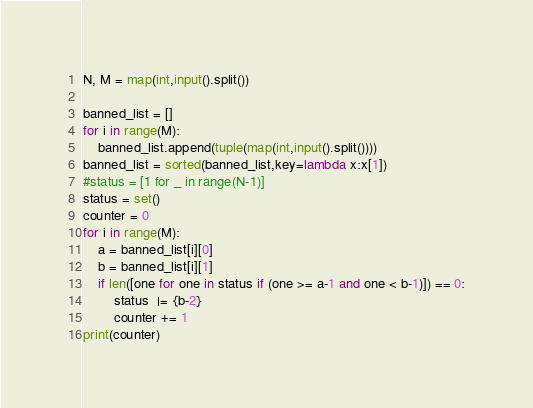<code> <loc_0><loc_0><loc_500><loc_500><_Python_>N, M = map(int,input().split())

banned_list = []
for i in range(M):
    banned_list.append(tuple(map(int,input().split())))
banned_list = sorted(banned_list,key=lambda x:x[1])
#status = [1 for _ in range(N-1)]
status = set()
counter = 0
for i in range(M):
    a = banned_list[i][0]
    b = banned_list[i][1]
    if len([one for one in status if (one >= a-1 and one < b-1)]) == 0:
        status  |= {b-2}
        counter += 1
print(counter)
</code> 